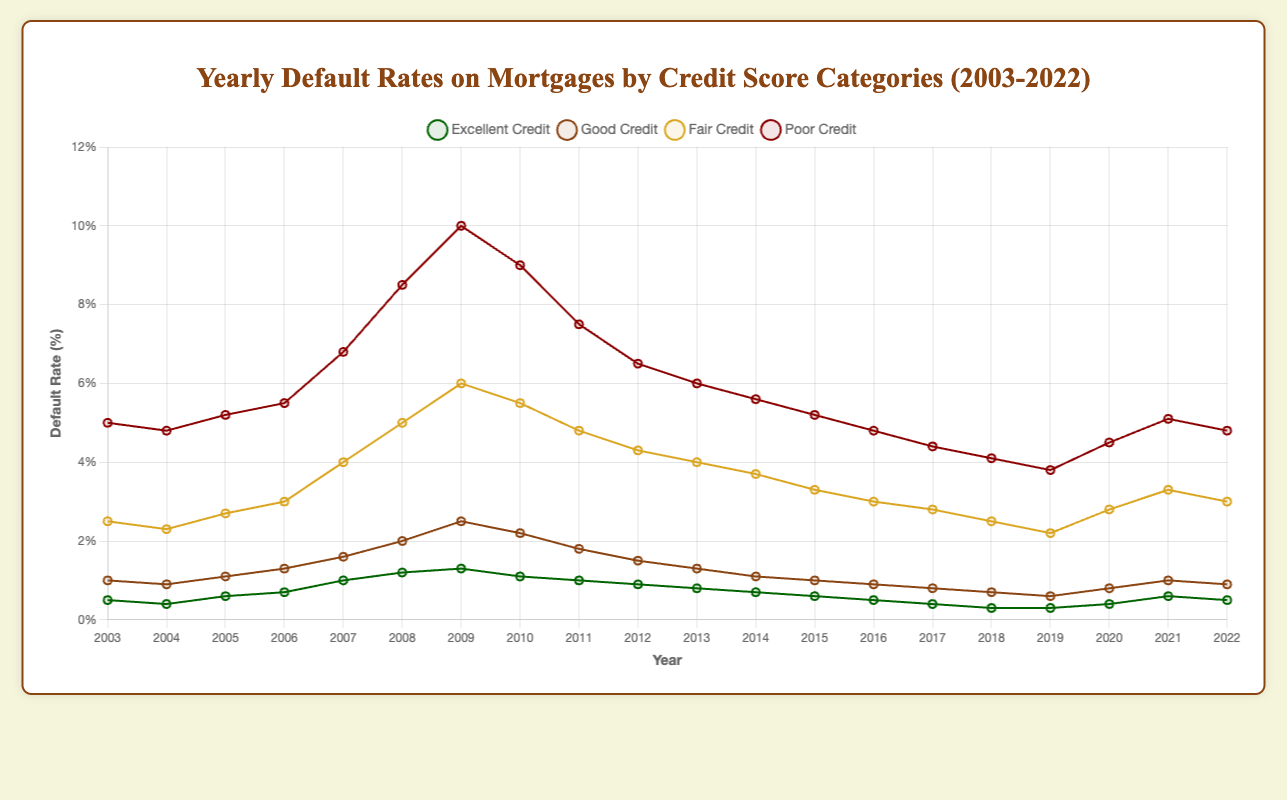What is the overall trend of mortgage default rates for poor credit since 2003? The trend can be identified by observing the line representing poor credit in the chart from 2003 to 2022. Initially, the default rate increased, peaking around 2009, and then declined gradually through 2022.
Answer: Increasing then decreasing Which credit score category had the highest default rate in 2008? By visually checking the plot for the year 2008, we observe that the line representing poor credit has the highest default rate.
Answer: Poor credit Compare the default rates of excellent credit and good credit in 2022. Which one is higher and by how much? By looking at the end of the chart for 2022, the default rate for excellent credit is 0.5% and for good credit is 0.9%. The difference is 0.9% - 0.5% = 0.4%.
Answer: Good credit by 0.4% What was the default rate for fair credit in 2010, and how does it compare to the rate in 2009? Checking the chart for the year 2010, the fair credit default rate is 5.5%. For 2009, it was 6.0%. The difference is 6.0% - 5.5% = 0.5%.
Answer: 5.5%, decreased by 0.5% Which year saw the highest default rate for excellent credit? By comparing the peak points of the excellent credit line, the highest peak is in 2009 with a default rate of 1.3%.
Answer: 2009 Calculate the average default rate for good credit from 2003 to 2022. Summing the default rates for good credit over these years: (1.0 + 0.9 + 1.1 + 1.3 + 1.6 + 2.0 + 2.5 + 2.2 + 1.8 + 1.5 + 1.3 + 1.1 + 1.0 + 0.9 + 0.8 + 0.7 + 0.6 + 0.8 + 1.0 + 0.9) = 28.2%. There are 20 years, so the average is 28.2 / 20 = 1.41%.
Answer: 1.41% From a visual perspective, which line is the most varied over the years and how can you tell? The poor credit line shows the most fluctuation in its height over the years, indicating higher variability. It experiences more drastic ups and downs compared to other categories.
Answer: Poor credit In which years did the default rate for fair credit exceed 5%? By inspecting the fair credit line, the years with rates above 5% are 2008, 2009, and 2010.
Answer: 2008, 2009, 2010 